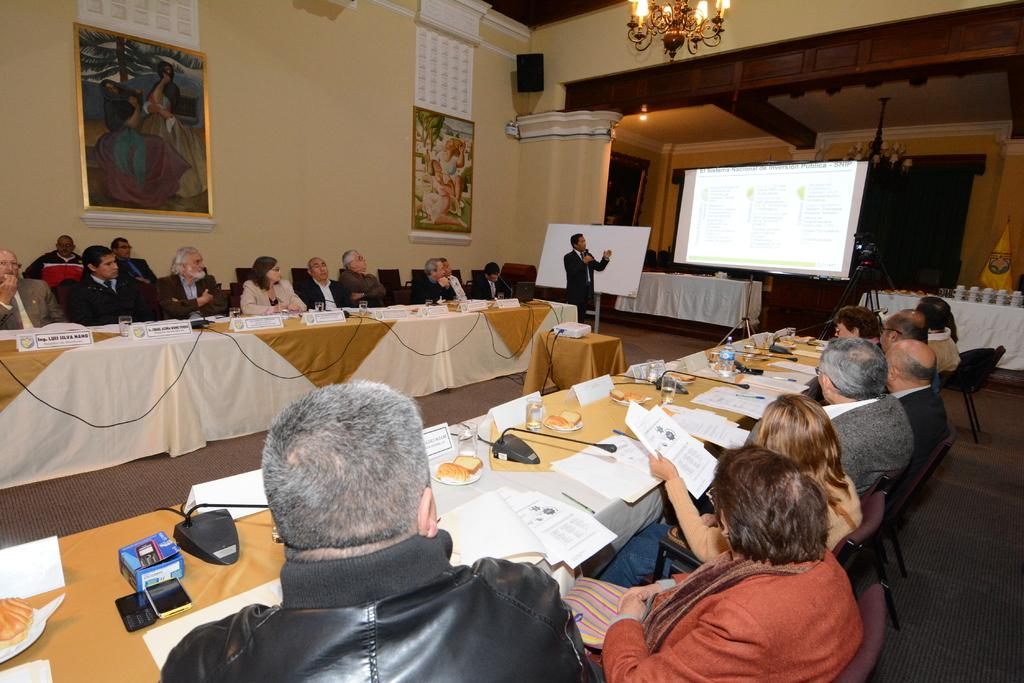What type of structure can be seen in the image? There is a wall in the image. What decorations are visible in the image? There are banners in the image. What device is present in the image? There is a screen in the image. What are the people in the image doing? There are people sitting on chairs in the image. What type of lighting fixture is present in the image? There is a chandelier in the image. What type of furniture is present in the image? There are tables in the image. What items can be seen on the tables? Papers, plates, mics, and bottles are present on the tables. How many tents are visible in the image? There are no tents present in the image. What type of transport is being used by the people in the image? There is no transport visible in the image; it is focused on a room with tables and chairs. 